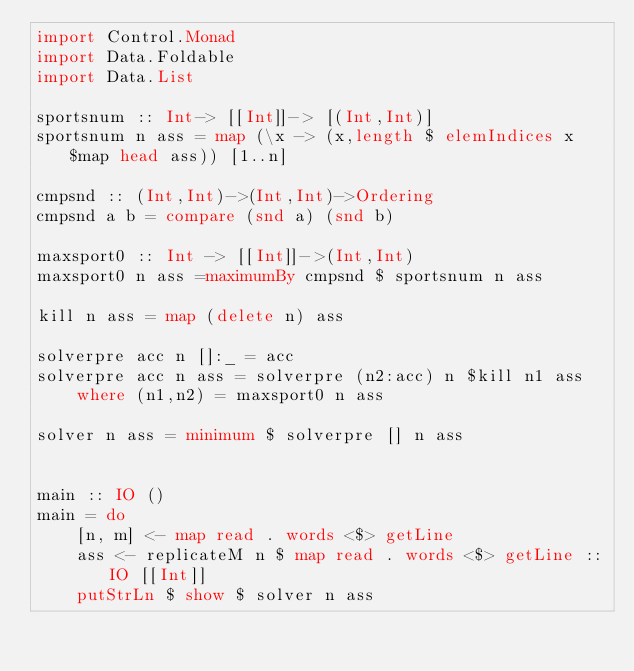Convert code to text. <code><loc_0><loc_0><loc_500><loc_500><_Haskell_>import Control.Monad
import Data.Foldable
import Data.List

sportsnum :: Int-> [[Int]]-> [(Int,Int)]
sportsnum n ass = map (\x -> (x,length $ elemIndices x $map head ass)) [1..n]

cmpsnd :: (Int,Int)->(Int,Int)->Ordering
cmpsnd a b = compare (snd a) (snd b)

maxsport0 :: Int -> [[Int]]->(Int,Int)
maxsport0 n ass =maximumBy cmpsnd $ sportsnum n ass

kill n ass = map (delete n) ass

solverpre acc n []:_ = acc
solverpre acc n ass = solverpre (n2:acc) n $kill n1 ass
    where (n1,n2) = maxsport0 n ass

solver n ass = minimum $ solverpre [] n ass


main :: IO ()
main = do
    [n, m] <- map read . words <$> getLine 
    ass <- replicateM n $ map read . words <$> getLine ::IO [[Int]]
    putStrLn $ show $ solver n ass

</code> 